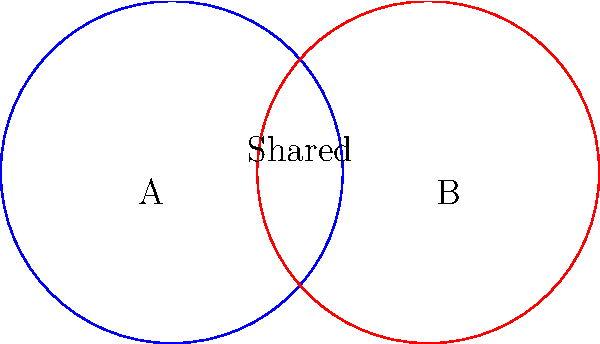As the director of a charitable organization, you're analyzing donor overlap between two fundraising campaigns. The Venn diagram shows two circles representing donor bases, each with a radius of 1 unit. If the centers of the circles are 1.5 units apart, what percentage of the total area is shared by both donor bases? Round your answer to the nearest whole percent. Let's approach this step-by-step:

1) First, we need to calculate the area of overlap between the two circles. The formula for this is:

   $$A_{overlap} = 2r^2 \arccos(\frac{d}{2r}) - d\sqrt{r^2 - \frac{d^2}{4}}$$

   where $r$ is the radius and $d$ is the distance between centers.

2) We're given that $r = 1$ and $d = 1.5$. Let's substitute these values:

   $$A_{overlap} = 2(1)^2 \arccos(\frac{1.5}{2(1)}) - 1.5\sqrt{1^2 - \frac{1.5^2}{4}}$$

3) Simplify:
   $$A_{overlap} = 2 \arccos(0.75) - 1.5\sqrt{1 - 0.5625}$$
   $$A_{overlap} = 2 \arccos(0.75) - 1.5\sqrt{0.4375}$$

4) Calculate:
   $$A_{overlap} \approx 2(0.7227) - 1.5(0.6614) \approx 0.4522$$

5) Now, we need to calculate the total area of both circles:
   $$A_{total} = 2\pi r^2 = 2\pi(1)^2 = 2\pi \approx 6.2832$$

6) The shared area as a percentage of the total area is:
   $$\frac{A_{overlap}}{A_{total}} \times 100\% = \frac{0.4522}{6.2832} \times 100\% \approx 7.20\%$$

7) Rounding to the nearest whole percent gives us 7%.
Answer: 7% 